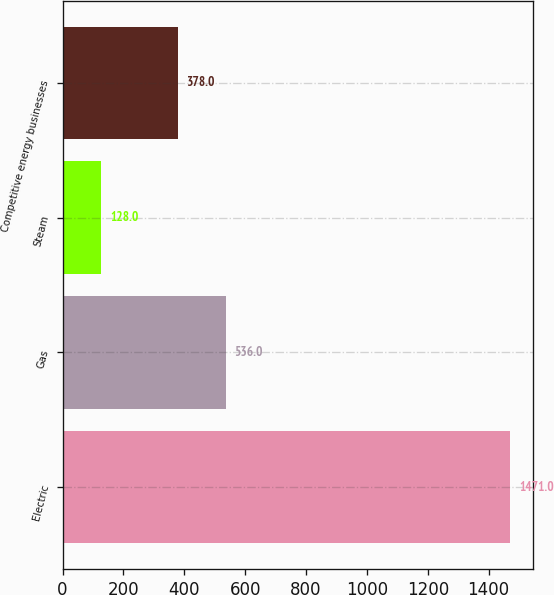<chart> <loc_0><loc_0><loc_500><loc_500><bar_chart><fcel>Electric<fcel>Gas<fcel>Steam<fcel>Competitive energy businesses<nl><fcel>1471<fcel>536<fcel>128<fcel>378<nl></chart> 